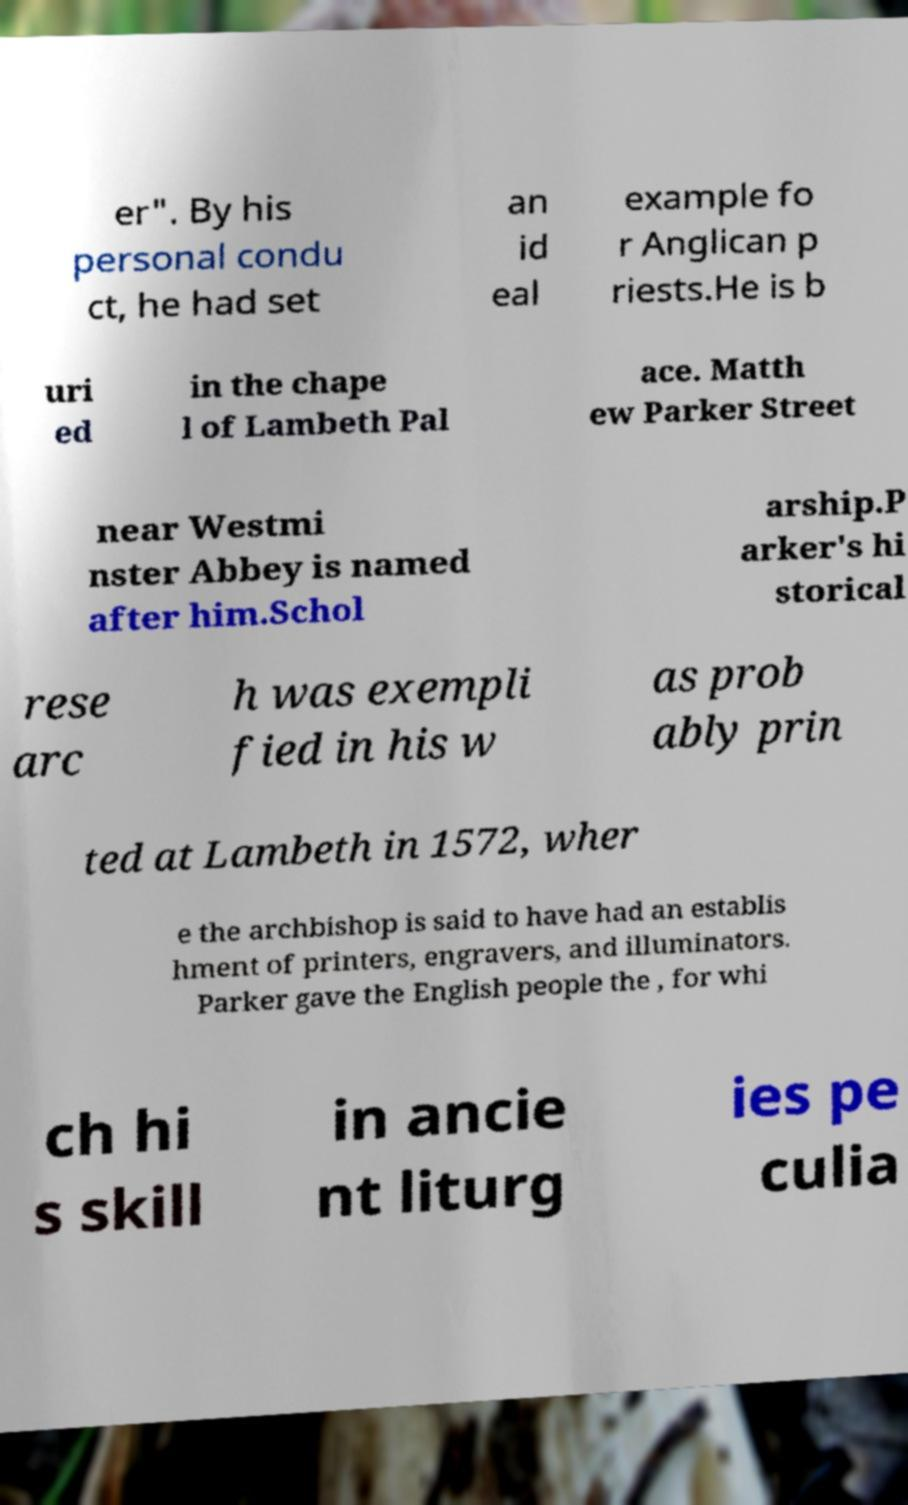Please identify and transcribe the text found in this image. er". By his personal condu ct, he had set an id eal example fo r Anglican p riests.He is b uri ed in the chape l of Lambeth Pal ace. Matth ew Parker Street near Westmi nster Abbey is named after him.Schol arship.P arker's hi storical rese arc h was exempli fied in his w as prob ably prin ted at Lambeth in 1572, wher e the archbishop is said to have had an establis hment of printers, engravers, and illuminators. Parker gave the English people the , for whi ch hi s skill in ancie nt liturg ies pe culia 